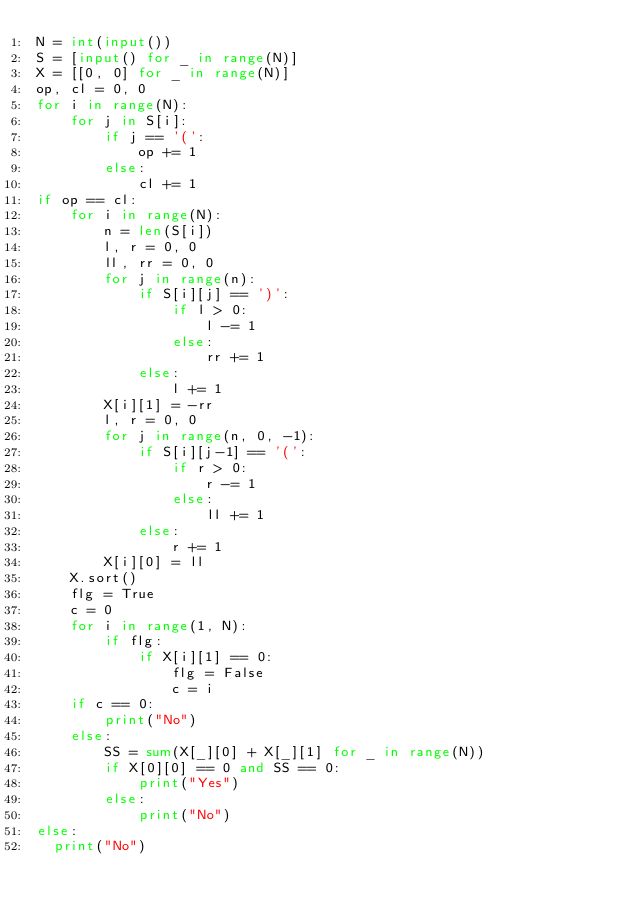<code> <loc_0><loc_0><loc_500><loc_500><_Python_>N = int(input())
S = [input() for _ in range(N)]
X = [[0, 0] for _ in range(N)]
op, cl = 0, 0
for i in range(N):
    for j in S[i]:
        if j == '(':
            op += 1
        else:
            cl += 1
if op == cl:
    for i in range(N):
        n = len(S[i])
        l, r = 0, 0
        ll, rr = 0, 0
        for j in range(n):
            if S[i][j] == ')':
                if l > 0:
                    l -= 1
                else:
                    rr += 1
            else:
                l += 1
        X[i][1] = -rr
        l, r = 0, 0
        for j in range(n, 0, -1):
            if S[i][j-1] == '(':
                if r > 0:
                    r -= 1
                else:
                    ll += 1
            else:
                r += 1
        X[i][0] = ll
    X.sort()
    flg = True
    c = 0
    for i in range(1, N):
        if flg:
            if X[i][1] == 0:
                flg = False
                c = i
    if c == 0:
        print("No")
    else:
        SS = sum(X[_][0] + X[_][1] for _ in range(N))
        if X[0][0] == 0 and SS == 0:
            print("Yes")
        else:
            print("No")
else:
  print("No")</code> 